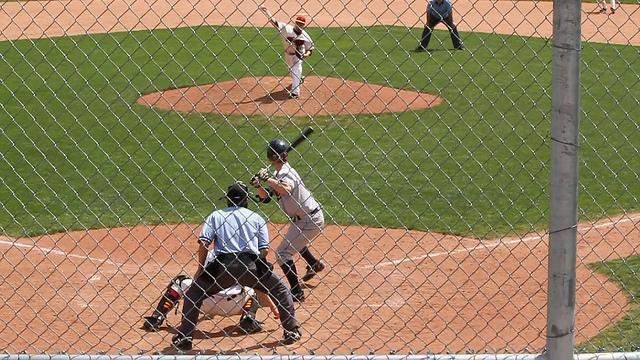How many people can be seen?
Give a very brief answer. 3. 